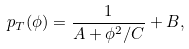<formula> <loc_0><loc_0><loc_500><loc_500>p _ { T } ( \phi ) = \frac { 1 } { A + \phi ^ { 2 } / C } + B ,</formula> 